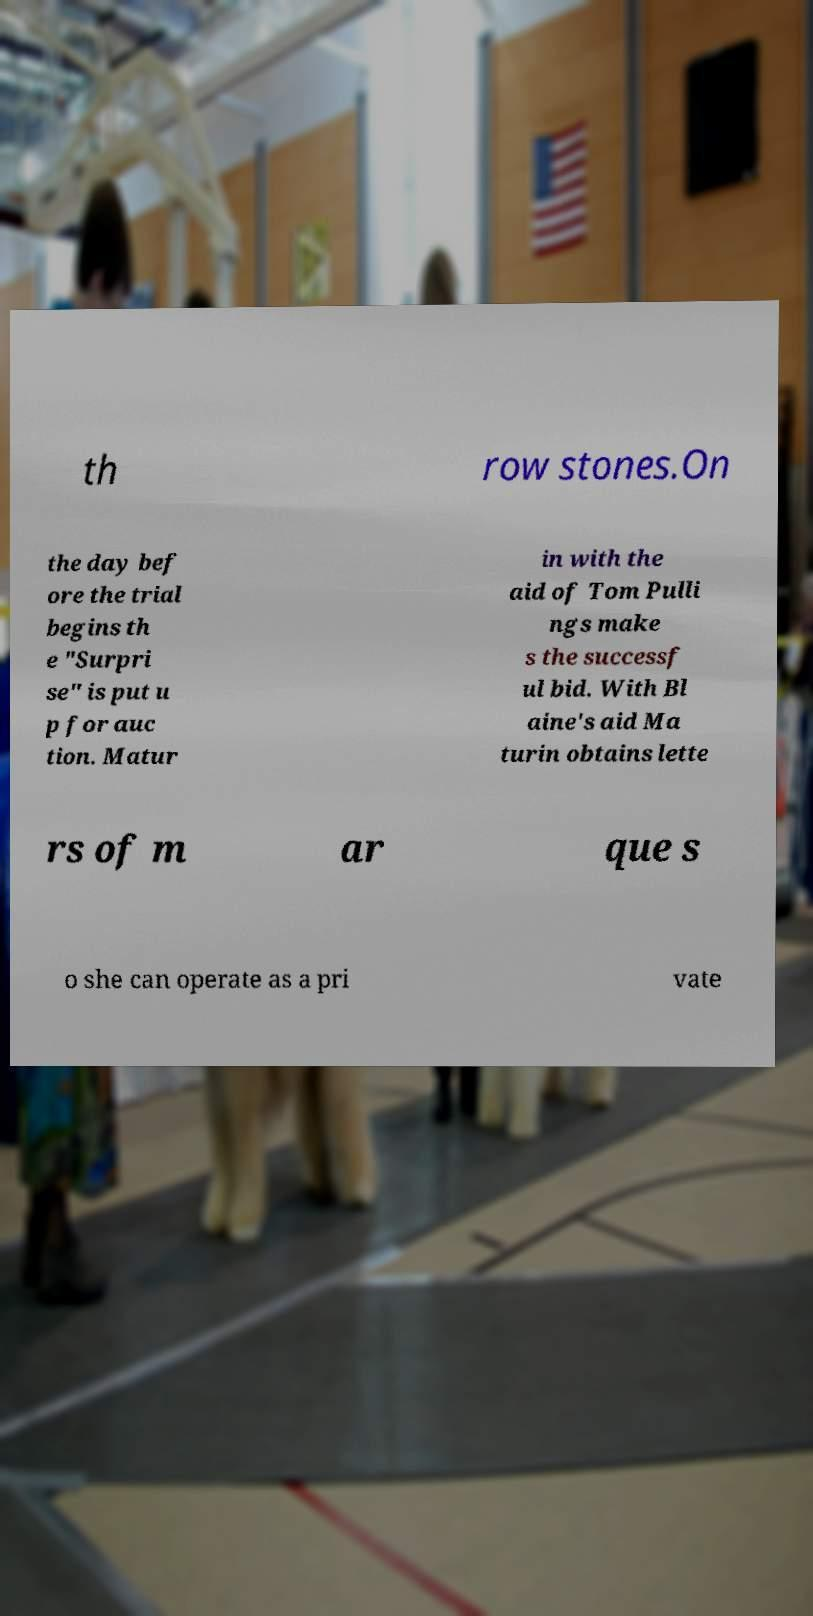Please read and relay the text visible in this image. What does it say? th row stones.On the day bef ore the trial begins th e "Surpri se" is put u p for auc tion. Matur in with the aid of Tom Pulli ngs make s the successf ul bid. With Bl aine's aid Ma turin obtains lette rs of m ar que s o she can operate as a pri vate 